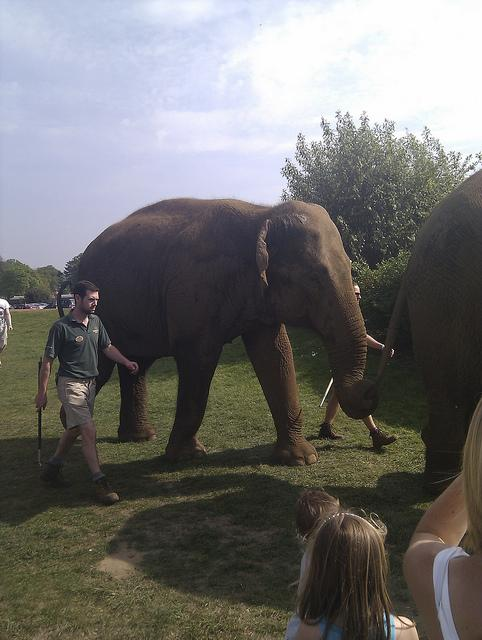What is the woman in white shirt likely to be doing? taking picture 